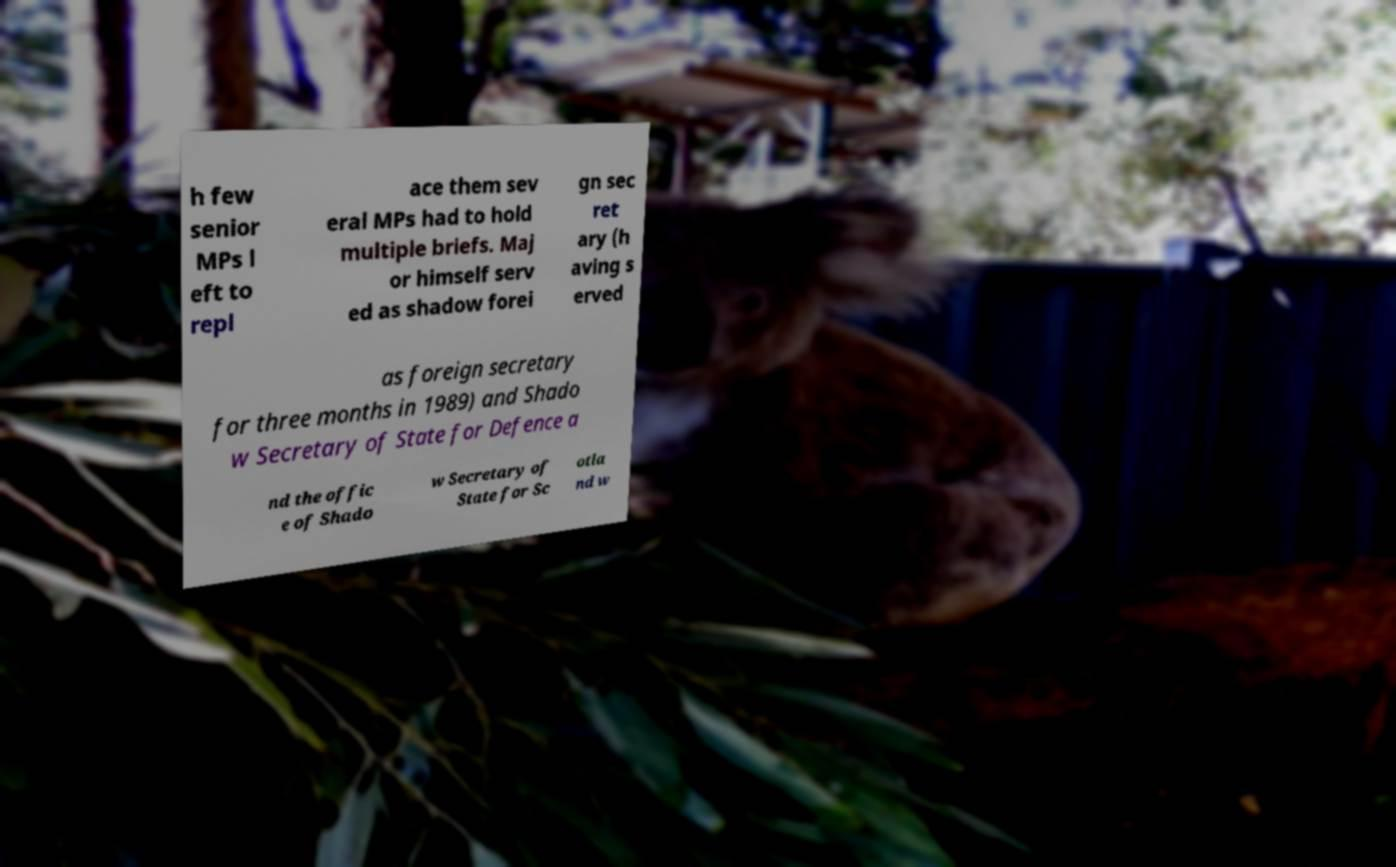Please identify and transcribe the text found in this image. h few senior MPs l eft to repl ace them sev eral MPs had to hold multiple briefs. Maj or himself serv ed as shadow forei gn sec ret ary (h aving s erved as foreign secretary for three months in 1989) and Shado w Secretary of State for Defence a nd the offic e of Shado w Secretary of State for Sc otla nd w 